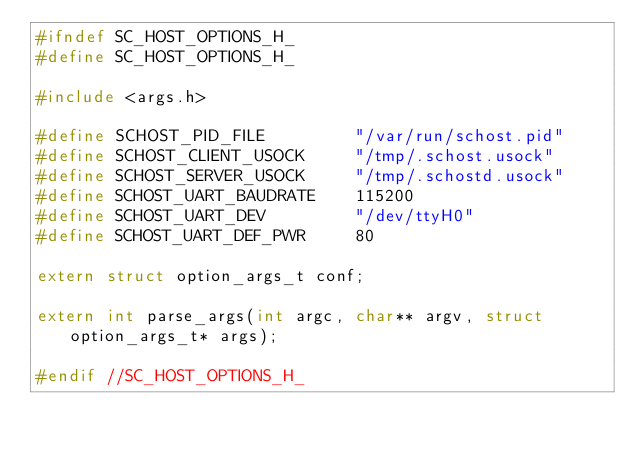<code> <loc_0><loc_0><loc_500><loc_500><_C_>#ifndef SC_HOST_OPTIONS_H_
#define SC_HOST_OPTIONS_H_

#include <args.h>

#define SCHOST_PID_FILE         "/var/run/schost.pid"
#define SCHOST_CLIENT_USOCK     "/tmp/.schost.usock"
#define SCHOST_SERVER_USOCK     "/tmp/.schostd.usock"
#define SCHOST_UART_BAUDRATE    115200
#define SCHOST_UART_DEV         "/dev/ttyH0"
#define SCHOST_UART_DEF_PWR     80

extern struct option_args_t conf;

extern int parse_args(int argc, char** argv, struct option_args_t* args);

#endif //SC_HOST_OPTIONS_H_
</code> 